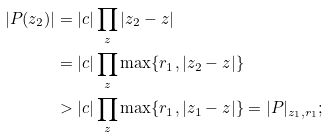Convert formula to latex. <formula><loc_0><loc_0><loc_500><loc_500>| P ( z _ { 2 } ) | & = | c | \prod _ { z } | z _ { 2 } - z | \\ & = | c | \prod _ { z } \max \{ r _ { 1 } , | z _ { 2 } - z | \} \\ & > | c | \prod _ { z } \max \{ r _ { 1 } , | z _ { 1 } - z | \} = | P | _ { z _ { 1 } , r _ { 1 } } ;</formula> 